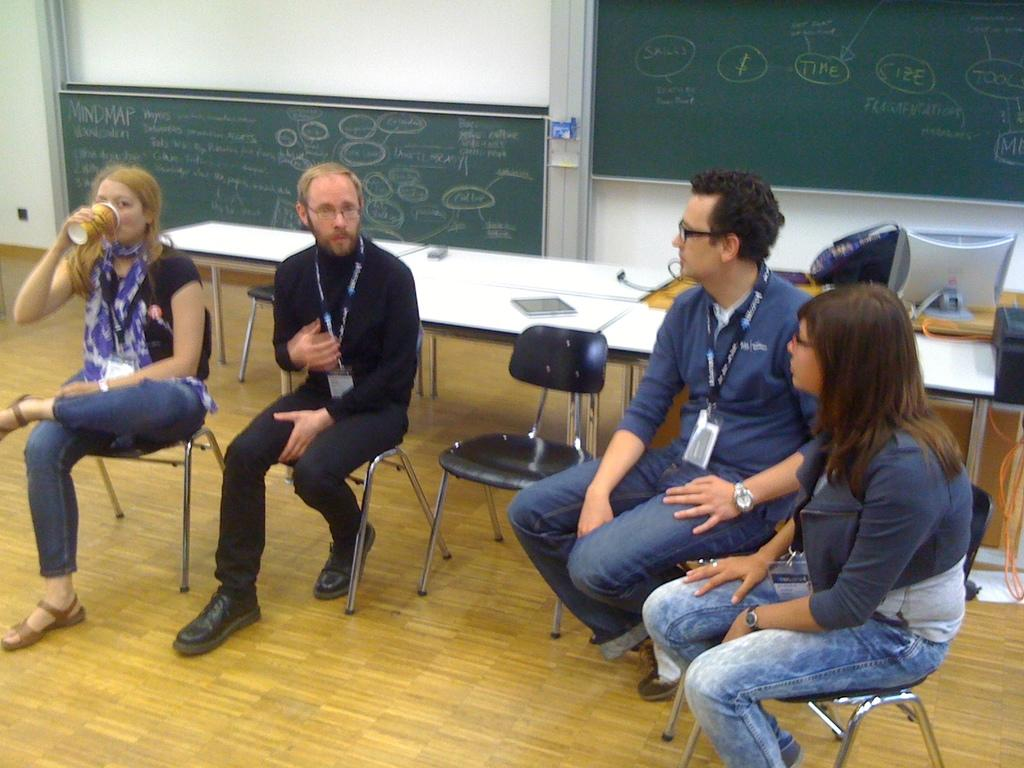What are the people in the image doing? The people in the image are sitting on chairs. What object can be seen in the image besides the chairs? There is a board in the image. What is the purpose of the board in the image? The board has writing on it, likely done with chalk, which suggests it might be a chalkboard or a similar surface for writing or displaying information. What color crayon is being used to write on the board in the image? There is no crayon present in the image; the writing on the board is likely done with chalk. What message of hope is written on the board in the image? There is no message of hope visible on the board in the image; it only has writing that is likely done with chalk. 